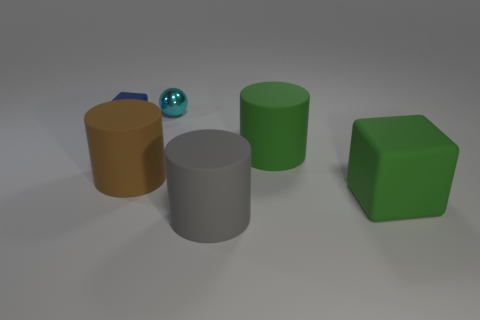There is a large brown thing that is the same shape as the big gray object; what material is it?
Offer a very short reply. Rubber. The large thing that is right of the big brown matte cylinder and behind the big rubber block is what color?
Provide a short and direct response. Green. The ball is what color?
Give a very brief answer. Cyan. What is the material of the thing that is the same color as the matte cube?
Your response must be concise. Rubber. Are there any big things that have the same shape as the tiny blue thing?
Your response must be concise. Yes. What size is the cube in front of the tiny cube?
Your answer should be compact. Large. There is a gray thing that is the same size as the green matte cylinder; what material is it?
Your response must be concise. Rubber. Are there more tiny objects than large red metallic cubes?
Make the answer very short. Yes. What size is the matte thing in front of the block to the right of the tiny blue block?
Your answer should be compact. Large. What is the shape of the brown matte thing that is the same size as the gray matte object?
Offer a terse response. Cylinder. 